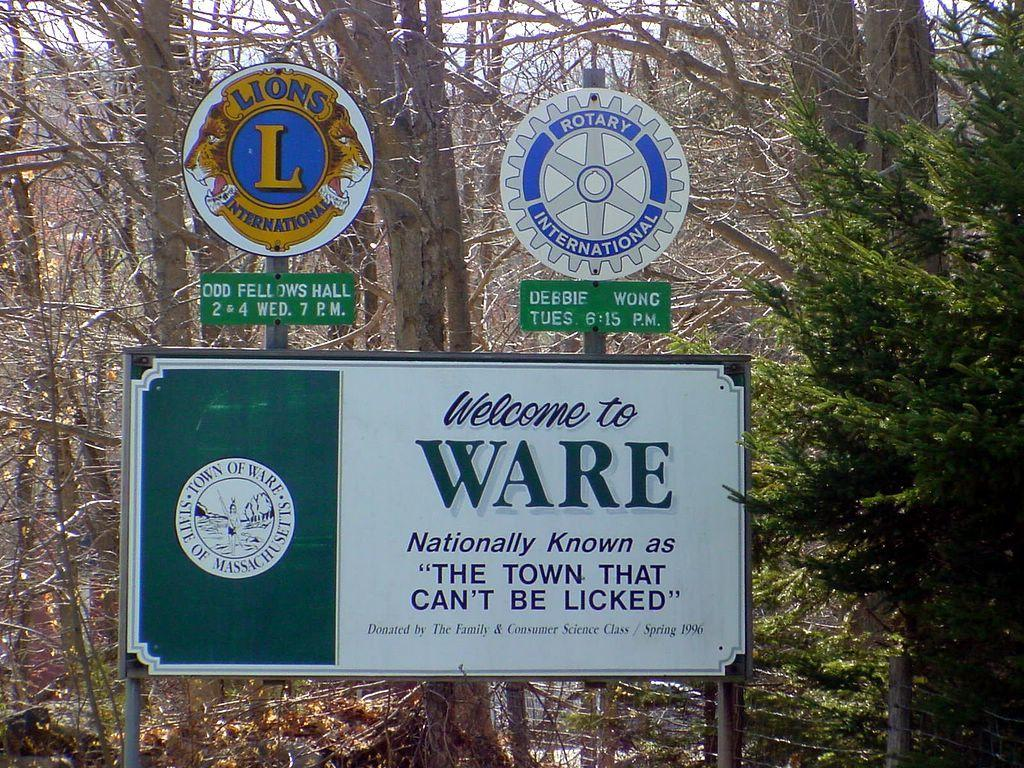<image>
Write a terse but informative summary of the picture. The sign welcomes you to Ware, the town that can't be licked. 